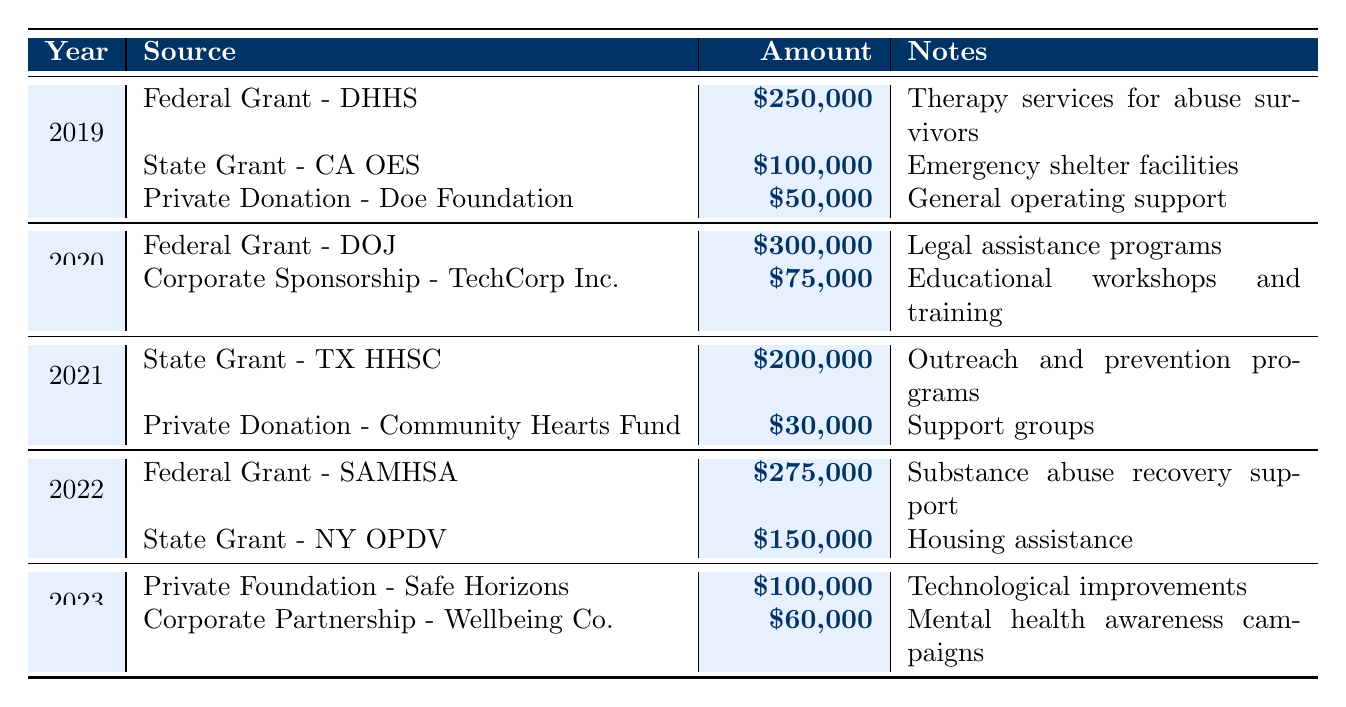What was the total funding received in 2019? In 2019, the organization received funding from three sources: Federal Grant (250,000), State Grant (100,000), and Private Donation (50,000). The total is calculated as 250,000 + 100,000 + 50,000 = 400,000.
Answer: 400,000 Which source contributed the most funding in 2020? In 2020, there were two funding sources: the Federal Grant (300,000) and Corporate Sponsorship (75,000). The Federal Grant amount is higher than the Corporate Sponsorship, making it the highest source of funding that year.
Answer: Federal Grant - Department of Justice How many different funding sources were there in 2021? In 2021, two sources contributed funds: State Grant (200,000) and Private Donation (30,000). Therefore, the count of distinct sources is 2.
Answer: 2 What is the difference in funding between 2022 and 2019? In 2022, the total funding was 275,000 (Federal Grant) + 150,000 (State Grant) = 425,000. In 2019, the total was 400,000. The difference is 425,000 - 400,000 = 25,000.
Answer: 25,000 Which year had the least amount of funding? The funding amounts per year are: 2019 (400,000), 2020 (375,000), 2021 (230,000), 2022 (425,000), and 2023 (160,000). The lowest amount is in 2021 with 230,000.
Answer: 2021 Was there any funding specifically allocated for technological improvements? The table shows a funding source in 2023 from the Private Foundation for technological improvements, confirming that such funding exists.
Answer: Yes What is the average amount of funding received per year over the specified period? The total funding from 2019 to 2023 is 400,000 + 375,000 + 230,000 + 425,000 + 160,000 = 1,590,000. There are 5 years, so the average is 1,590,000 / 5 = 318,000.
Answer: 318,000 How much funding was specifically directed toward legal assistance programs? The funding amount for legal assistance programs in 2020 is 300,000 from the Federal Grant. This is the only entry focused on legal assistance programs.
Answer: 300,000 What percentage of the total funding in 2023 was contributed by the Corporate Partnership? In 2023, the total funding was 100,000 (Private Foundation) + 60,000 (Corporate Partnership) = 160,000. The Corporate Partnership contributed 60,000. The percentage is (60,000 / 160,000) * 100 = 37.5%.
Answer: 37.5% Which year saw an increase in funding compared to the previous year? Comparing the years, 2022 (425,000) saw an increase from 2021 (230,000). 2020 (375,000) increased from 2019 (400,000) but is not a valid increase, only a decrease. Thus, 2022 is the correct answer.
Answer: 2022 